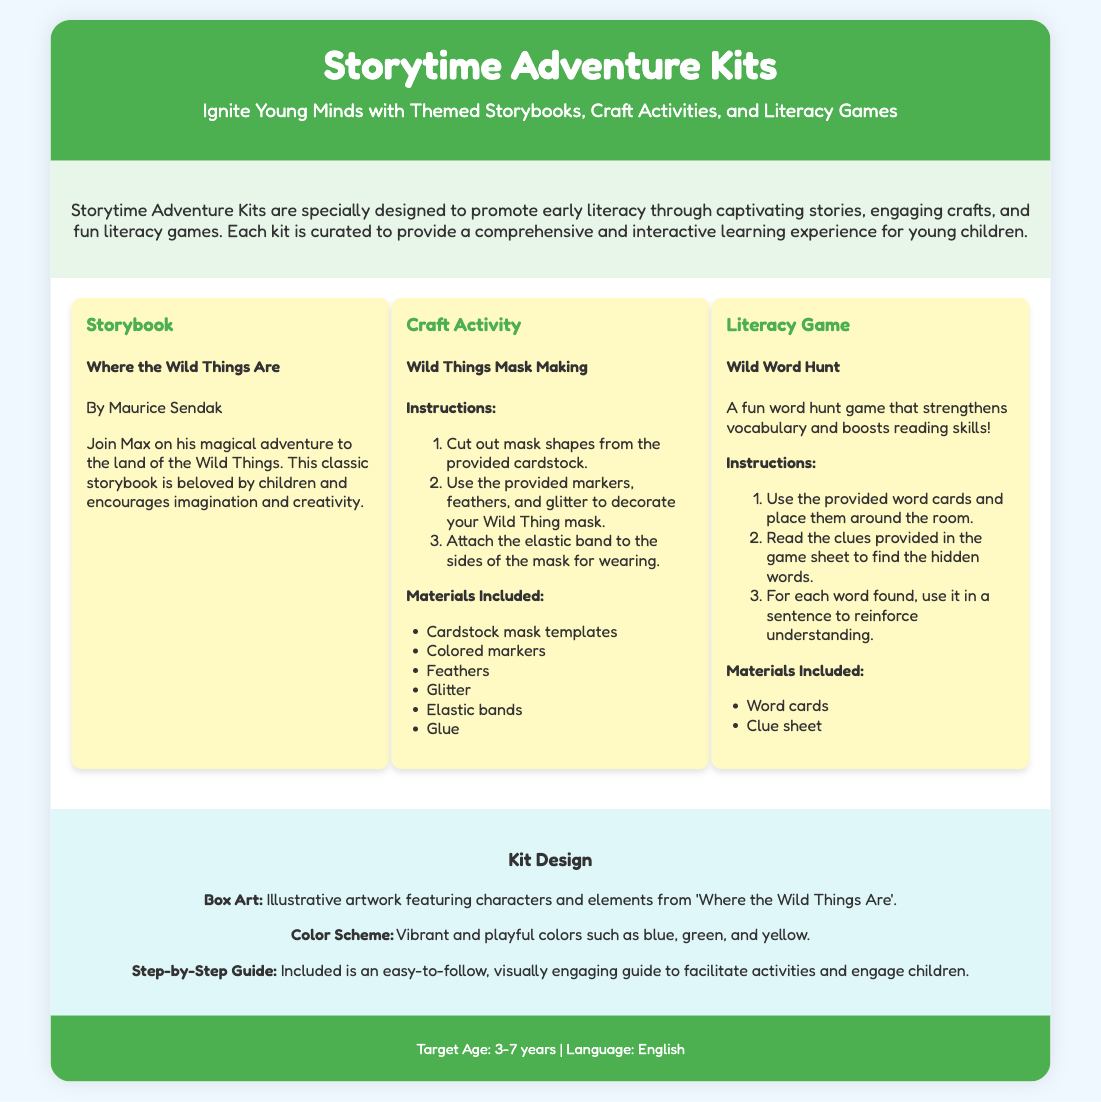what is the title of the storybook included in the kit? The title of the storybook is mentioned prominently in the "Storybook" section.
Answer: Where the Wild Things Are who is the author of the storybook? The author is specified right under the storybook title in the same section.
Answer: Maurice Sendak what activity is suggested for craft making? The craft activity is listed with its title in the "Craft Activity" section.
Answer: Wild Things Mask Making how many materials are included for the craft activity? The number of materials can be counted from the list provided in the craft activity section.
Answer: Six what is the name of the literacy game? The name of the literacy game is given in the "Literacy Game" section title.
Answer: Wild Word Hunt what age group is the kit designed for? The target age group is stated clearly in the footer of the document.
Answer: 3-7 years what are the colors used in the box design? The color scheme is summarized in the "Kit Design" section.
Answer: Blue, green, and yellow what is the purpose of the step-by-step guide included in the kit? The purpose is explained in the "Kit Design" section referring to how to facilitate activities.
Answer: Facilitate activities what type of experience does the Storytime Adventure Kits aim to provide? The overall goal of the kits is mentioned in the description section at the beginning.
Answer: Comprehensive and interactive learning experience 